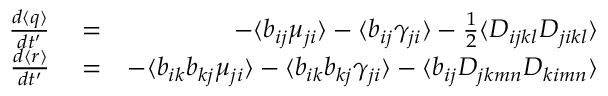Convert formula to latex. <formula><loc_0><loc_0><loc_500><loc_500>\begin{array} { r l r } { \frac { d \langle q \rangle } { d t ^ { \prime } } } & = } & { - \langle b _ { i j } \mu _ { j i } \rangle - \langle b _ { i j } \gamma _ { j i } \rangle - \frac { 1 } { 2 } \langle D _ { i j k l } D _ { j i k l } \rangle } \\ { \frac { d \langle r \rangle } { d t ^ { \prime } } } & = } & { - \langle b _ { i k } b _ { k j } \mu _ { j i } \rangle - \langle b _ { i k } b _ { k j } \gamma _ { j i } \rangle - \langle b _ { i j } D _ { j k m n } D _ { k i m n } \rangle } \end{array}</formula> 